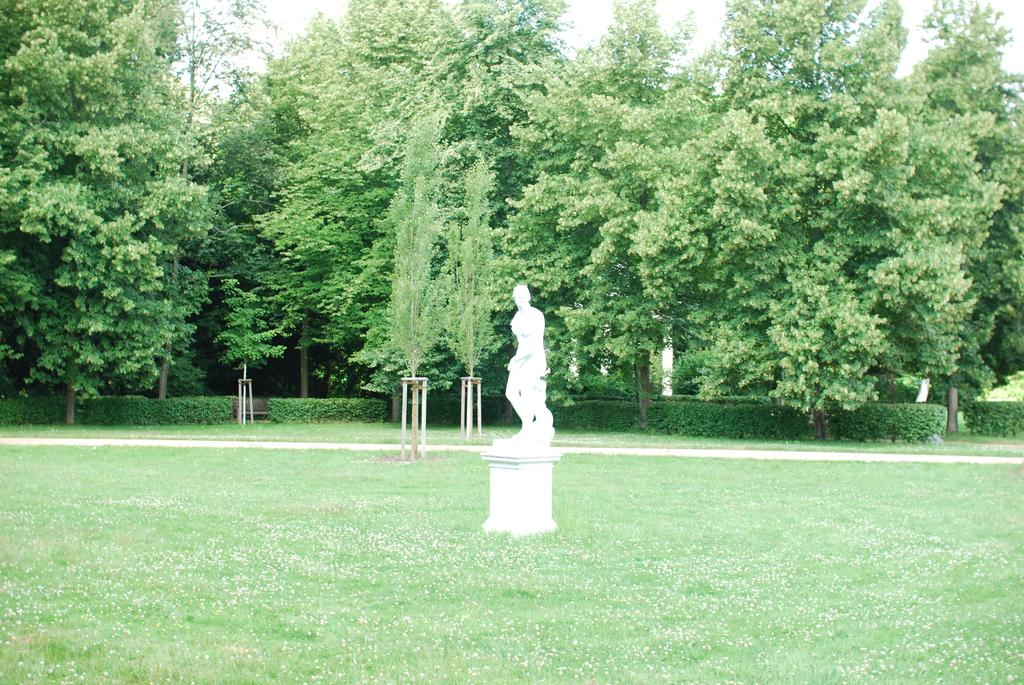What type of vegetation can be seen in the image? There are trees in the image. What is located on the ground in front of the trees? There is a white color statue on the ground. What else can be seen in front of the trees? Bushes are visible in front of the trees. What type of grain is being transported by the jelly in the image? There is no grain or jelly present in the image. 